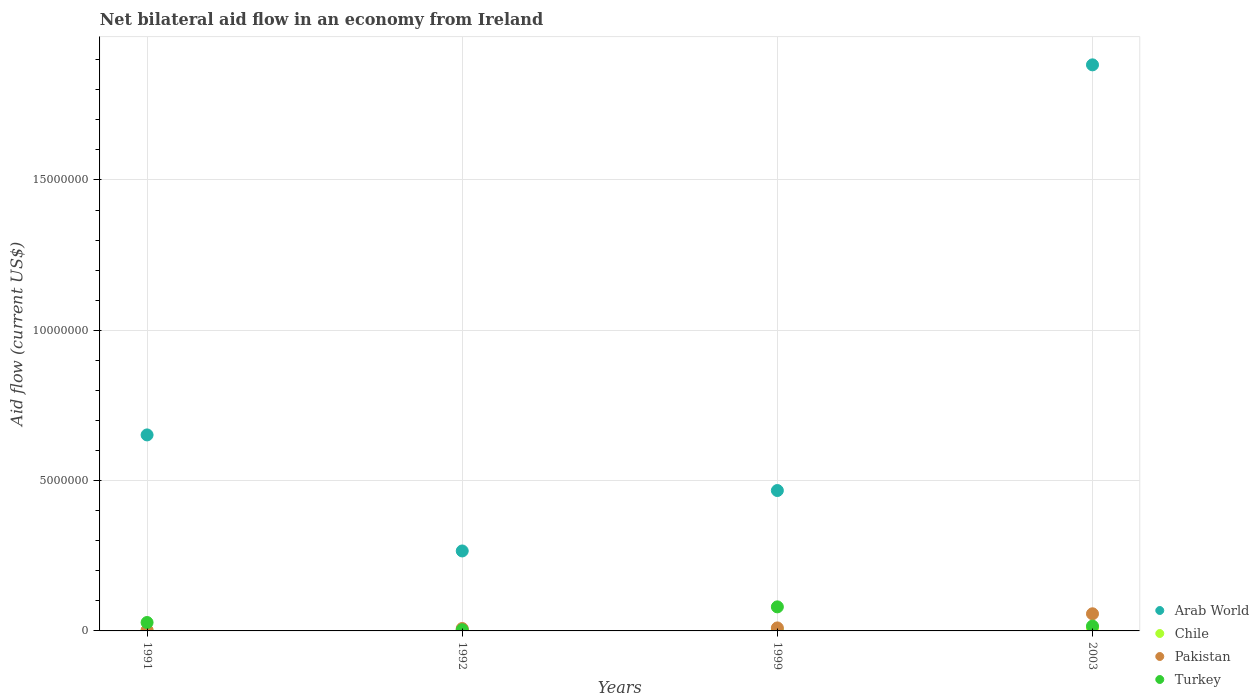How many different coloured dotlines are there?
Offer a terse response. 4. What is the net bilateral aid flow in Arab World in 1992?
Ensure brevity in your answer.  2.66e+06. Across all years, what is the minimum net bilateral aid flow in Arab World?
Your answer should be very brief. 2.66e+06. In which year was the net bilateral aid flow in Pakistan minimum?
Provide a short and direct response. 1991. What is the total net bilateral aid flow in Chile in the graph?
Keep it short and to the point. 1.70e+05. What is the difference between the net bilateral aid flow in Arab World in 1999 and that in 2003?
Provide a short and direct response. -1.42e+07. What is the difference between the net bilateral aid flow in Arab World in 1991 and the net bilateral aid flow in Chile in 2003?
Ensure brevity in your answer.  6.42e+06. What is the average net bilateral aid flow in Turkey per year?
Your answer should be very brief. 3.20e+05. In the year 1999, what is the difference between the net bilateral aid flow in Pakistan and net bilateral aid flow in Turkey?
Your response must be concise. -7.00e+05. What is the ratio of the net bilateral aid flow in Arab World in 1991 to that in 2003?
Give a very brief answer. 0.35. Is the difference between the net bilateral aid flow in Pakistan in 1992 and 2003 greater than the difference between the net bilateral aid flow in Turkey in 1992 and 2003?
Offer a very short reply. No. What is the difference between the highest and the second highest net bilateral aid flow in Turkey?
Give a very brief answer. 5.20e+05. What is the difference between the highest and the lowest net bilateral aid flow in Arab World?
Your response must be concise. 1.62e+07. Is the sum of the net bilateral aid flow in Turkey in 1992 and 1999 greater than the maximum net bilateral aid flow in Pakistan across all years?
Offer a terse response. Yes. Is it the case that in every year, the sum of the net bilateral aid flow in Pakistan and net bilateral aid flow in Turkey  is greater than the sum of net bilateral aid flow in Arab World and net bilateral aid flow in Chile?
Keep it short and to the point. No. Is it the case that in every year, the sum of the net bilateral aid flow in Turkey and net bilateral aid flow in Arab World  is greater than the net bilateral aid flow in Chile?
Your answer should be compact. Yes. How many dotlines are there?
Offer a very short reply. 4. How many years are there in the graph?
Keep it short and to the point. 4. What is the difference between two consecutive major ticks on the Y-axis?
Offer a very short reply. 5.00e+06. How many legend labels are there?
Your response must be concise. 4. What is the title of the graph?
Provide a short and direct response. Net bilateral aid flow in an economy from Ireland. Does "High income: OECD" appear as one of the legend labels in the graph?
Make the answer very short. No. What is the Aid flow (current US$) of Arab World in 1991?
Offer a very short reply. 6.52e+06. What is the Aid flow (current US$) of Chile in 1991?
Keep it short and to the point. 2.00e+04. What is the Aid flow (current US$) in Turkey in 1991?
Provide a short and direct response. 2.80e+05. What is the Aid flow (current US$) of Arab World in 1992?
Offer a terse response. 2.66e+06. What is the Aid flow (current US$) in Pakistan in 1992?
Provide a succinct answer. 8.00e+04. What is the Aid flow (current US$) of Arab World in 1999?
Make the answer very short. 4.67e+06. What is the Aid flow (current US$) in Chile in 1999?
Offer a terse response. 3.00e+04. What is the Aid flow (current US$) of Pakistan in 1999?
Provide a succinct answer. 1.00e+05. What is the Aid flow (current US$) of Turkey in 1999?
Your answer should be very brief. 8.00e+05. What is the Aid flow (current US$) of Arab World in 2003?
Keep it short and to the point. 1.88e+07. What is the Aid flow (current US$) in Pakistan in 2003?
Offer a very short reply. 5.70e+05. What is the Aid flow (current US$) in Turkey in 2003?
Your response must be concise. 1.60e+05. Across all years, what is the maximum Aid flow (current US$) in Arab World?
Your answer should be compact. 1.88e+07. Across all years, what is the maximum Aid flow (current US$) in Chile?
Provide a short and direct response. 1.00e+05. Across all years, what is the maximum Aid flow (current US$) in Pakistan?
Offer a terse response. 5.70e+05. Across all years, what is the minimum Aid flow (current US$) of Arab World?
Make the answer very short. 2.66e+06. Across all years, what is the minimum Aid flow (current US$) in Pakistan?
Give a very brief answer. 2.00e+04. What is the total Aid flow (current US$) in Arab World in the graph?
Provide a short and direct response. 3.27e+07. What is the total Aid flow (current US$) in Pakistan in the graph?
Your response must be concise. 7.70e+05. What is the total Aid flow (current US$) of Turkey in the graph?
Give a very brief answer. 1.28e+06. What is the difference between the Aid flow (current US$) in Arab World in 1991 and that in 1992?
Give a very brief answer. 3.86e+06. What is the difference between the Aid flow (current US$) in Pakistan in 1991 and that in 1992?
Provide a short and direct response. -6.00e+04. What is the difference between the Aid flow (current US$) of Arab World in 1991 and that in 1999?
Offer a terse response. 1.85e+06. What is the difference between the Aid flow (current US$) in Chile in 1991 and that in 1999?
Offer a very short reply. -10000. What is the difference between the Aid flow (current US$) of Pakistan in 1991 and that in 1999?
Offer a terse response. -8.00e+04. What is the difference between the Aid flow (current US$) of Turkey in 1991 and that in 1999?
Your answer should be very brief. -5.20e+05. What is the difference between the Aid flow (current US$) in Arab World in 1991 and that in 2003?
Provide a succinct answer. -1.23e+07. What is the difference between the Aid flow (current US$) in Pakistan in 1991 and that in 2003?
Give a very brief answer. -5.50e+05. What is the difference between the Aid flow (current US$) of Turkey in 1991 and that in 2003?
Offer a terse response. 1.20e+05. What is the difference between the Aid flow (current US$) of Arab World in 1992 and that in 1999?
Your answer should be very brief. -2.01e+06. What is the difference between the Aid flow (current US$) in Turkey in 1992 and that in 1999?
Provide a short and direct response. -7.60e+05. What is the difference between the Aid flow (current US$) of Arab World in 1992 and that in 2003?
Your response must be concise. -1.62e+07. What is the difference between the Aid flow (current US$) of Chile in 1992 and that in 2003?
Provide a succinct answer. -8.00e+04. What is the difference between the Aid flow (current US$) in Pakistan in 1992 and that in 2003?
Provide a short and direct response. -4.90e+05. What is the difference between the Aid flow (current US$) in Arab World in 1999 and that in 2003?
Offer a terse response. -1.42e+07. What is the difference between the Aid flow (current US$) of Pakistan in 1999 and that in 2003?
Keep it short and to the point. -4.70e+05. What is the difference between the Aid flow (current US$) in Turkey in 1999 and that in 2003?
Provide a succinct answer. 6.40e+05. What is the difference between the Aid flow (current US$) of Arab World in 1991 and the Aid flow (current US$) of Chile in 1992?
Keep it short and to the point. 6.50e+06. What is the difference between the Aid flow (current US$) in Arab World in 1991 and the Aid flow (current US$) in Pakistan in 1992?
Make the answer very short. 6.44e+06. What is the difference between the Aid flow (current US$) of Arab World in 1991 and the Aid flow (current US$) of Turkey in 1992?
Your answer should be compact. 6.48e+06. What is the difference between the Aid flow (current US$) of Chile in 1991 and the Aid flow (current US$) of Pakistan in 1992?
Give a very brief answer. -6.00e+04. What is the difference between the Aid flow (current US$) of Chile in 1991 and the Aid flow (current US$) of Turkey in 1992?
Keep it short and to the point. -2.00e+04. What is the difference between the Aid flow (current US$) of Pakistan in 1991 and the Aid flow (current US$) of Turkey in 1992?
Your response must be concise. -2.00e+04. What is the difference between the Aid flow (current US$) in Arab World in 1991 and the Aid flow (current US$) in Chile in 1999?
Offer a terse response. 6.49e+06. What is the difference between the Aid flow (current US$) in Arab World in 1991 and the Aid flow (current US$) in Pakistan in 1999?
Offer a very short reply. 6.42e+06. What is the difference between the Aid flow (current US$) in Arab World in 1991 and the Aid flow (current US$) in Turkey in 1999?
Keep it short and to the point. 5.72e+06. What is the difference between the Aid flow (current US$) of Chile in 1991 and the Aid flow (current US$) of Pakistan in 1999?
Your answer should be very brief. -8.00e+04. What is the difference between the Aid flow (current US$) of Chile in 1991 and the Aid flow (current US$) of Turkey in 1999?
Your response must be concise. -7.80e+05. What is the difference between the Aid flow (current US$) of Pakistan in 1991 and the Aid flow (current US$) of Turkey in 1999?
Provide a short and direct response. -7.80e+05. What is the difference between the Aid flow (current US$) of Arab World in 1991 and the Aid flow (current US$) of Chile in 2003?
Your answer should be compact. 6.42e+06. What is the difference between the Aid flow (current US$) in Arab World in 1991 and the Aid flow (current US$) in Pakistan in 2003?
Offer a terse response. 5.95e+06. What is the difference between the Aid flow (current US$) in Arab World in 1991 and the Aid flow (current US$) in Turkey in 2003?
Make the answer very short. 6.36e+06. What is the difference between the Aid flow (current US$) of Chile in 1991 and the Aid flow (current US$) of Pakistan in 2003?
Your answer should be very brief. -5.50e+05. What is the difference between the Aid flow (current US$) in Pakistan in 1991 and the Aid flow (current US$) in Turkey in 2003?
Provide a succinct answer. -1.40e+05. What is the difference between the Aid flow (current US$) of Arab World in 1992 and the Aid flow (current US$) of Chile in 1999?
Provide a short and direct response. 2.63e+06. What is the difference between the Aid flow (current US$) of Arab World in 1992 and the Aid flow (current US$) of Pakistan in 1999?
Your answer should be very brief. 2.56e+06. What is the difference between the Aid flow (current US$) of Arab World in 1992 and the Aid flow (current US$) of Turkey in 1999?
Your answer should be very brief. 1.86e+06. What is the difference between the Aid flow (current US$) of Chile in 1992 and the Aid flow (current US$) of Pakistan in 1999?
Ensure brevity in your answer.  -8.00e+04. What is the difference between the Aid flow (current US$) in Chile in 1992 and the Aid flow (current US$) in Turkey in 1999?
Offer a very short reply. -7.80e+05. What is the difference between the Aid flow (current US$) of Pakistan in 1992 and the Aid flow (current US$) of Turkey in 1999?
Provide a short and direct response. -7.20e+05. What is the difference between the Aid flow (current US$) of Arab World in 1992 and the Aid flow (current US$) of Chile in 2003?
Provide a short and direct response. 2.56e+06. What is the difference between the Aid flow (current US$) in Arab World in 1992 and the Aid flow (current US$) in Pakistan in 2003?
Give a very brief answer. 2.09e+06. What is the difference between the Aid flow (current US$) in Arab World in 1992 and the Aid flow (current US$) in Turkey in 2003?
Offer a very short reply. 2.50e+06. What is the difference between the Aid flow (current US$) of Chile in 1992 and the Aid flow (current US$) of Pakistan in 2003?
Give a very brief answer. -5.50e+05. What is the difference between the Aid flow (current US$) in Pakistan in 1992 and the Aid flow (current US$) in Turkey in 2003?
Keep it short and to the point. -8.00e+04. What is the difference between the Aid flow (current US$) of Arab World in 1999 and the Aid flow (current US$) of Chile in 2003?
Your answer should be very brief. 4.57e+06. What is the difference between the Aid flow (current US$) in Arab World in 1999 and the Aid flow (current US$) in Pakistan in 2003?
Offer a terse response. 4.10e+06. What is the difference between the Aid flow (current US$) of Arab World in 1999 and the Aid flow (current US$) of Turkey in 2003?
Your response must be concise. 4.51e+06. What is the difference between the Aid flow (current US$) of Chile in 1999 and the Aid flow (current US$) of Pakistan in 2003?
Make the answer very short. -5.40e+05. What is the difference between the Aid flow (current US$) in Chile in 1999 and the Aid flow (current US$) in Turkey in 2003?
Provide a succinct answer. -1.30e+05. What is the difference between the Aid flow (current US$) in Pakistan in 1999 and the Aid flow (current US$) in Turkey in 2003?
Your answer should be compact. -6.00e+04. What is the average Aid flow (current US$) of Arab World per year?
Offer a very short reply. 8.17e+06. What is the average Aid flow (current US$) in Chile per year?
Offer a very short reply. 4.25e+04. What is the average Aid flow (current US$) in Pakistan per year?
Give a very brief answer. 1.92e+05. What is the average Aid flow (current US$) in Turkey per year?
Offer a terse response. 3.20e+05. In the year 1991, what is the difference between the Aid flow (current US$) in Arab World and Aid flow (current US$) in Chile?
Provide a succinct answer. 6.50e+06. In the year 1991, what is the difference between the Aid flow (current US$) in Arab World and Aid flow (current US$) in Pakistan?
Provide a short and direct response. 6.50e+06. In the year 1991, what is the difference between the Aid flow (current US$) of Arab World and Aid flow (current US$) of Turkey?
Give a very brief answer. 6.24e+06. In the year 1992, what is the difference between the Aid flow (current US$) in Arab World and Aid flow (current US$) in Chile?
Give a very brief answer. 2.64e+06. In the year 1992, what is the difference between the Aid flow (current US$) in Arab World and Aid flow (current US$) in Pakistan?
Offer a terse response. 2.58e+06. In the year 1992, what is the difference between the Aid flow (current US$) of Arab World and Aid flow (current US$) of Turkey?
Your answer should be very brief. 2.62e+06. In the year 1992, what is the difference between the Aid flow (current US$) in Chile and Aid flow (current US$) in Turkey?
Keep it short and to the point. -2.00e+04. In the year 1999, what is the difference between the Aid flow (current US$) of Arab World and Aid flow (current US$) of Chile?
Your answer should be compact. 4.64e+06. In the year 1999, what is the difference between the Aid flow (current US$) of Arab World and Aid flow (current US$) of Pakistan?
Offer a terse response. 4.57e+06. In the year 1999, what is the difference between the Aid flow (current US$) in Arab World and Aid flow (current US$) in Turkey?
Give a very brief answer. 3.87e+06. In the year 1999, what is the difference between the Aid flow (current US$) in Chile and Aid flow (current US$) in Pakistan?
Your response must be concise. -7.00e+04. In the year 1999, what is the difference between the Aid flow (current US$) of Chile and Aid flow (current US$) of Turkey?
Keep it short and to the point. -7.70e+05. In the year 1999, what is the difference between the Aid flow (current US$) in Pakistan and Aid flow (current US$) in Turkey?
Give a very brief answer. -7.00e+05. In the year 2003, what is the difference between the Aid flow (current US$) in Arab World and Aid flow (current US$) in Chile?
Make the answer very short. 1.87e+07. In the year 2003, what is the difference between the Aid flow (current US$) in Arab World and Aid flow (current US$) in Pakistan?
Offer a terse response. 1.83e+07. In the year 2003, what is the difference between the Aid flow (current US$) in Arab World and Aid flow (current US$) in Turkey?
Provide a short and direct response. 1.87e+07. In the year 2003, what is the difference between the Aid flow (current US$) in Chile and Aid flow (current US$) in Pakistan?
Provide a succinct answer. -4.70e+05. In the year 2003, what is the difference between the Aid flow (current US$) of Chile and Aid flow (current US$) of Turkey?
Offer a very short reply. -6.00e+04. What is the ratio of the Aid flow (current US$) of Arab World in 1991 to that in 1992?
Give a very brief answer. 2.45. What is the ratio of the Aid flow (current US$) of Chile in 1991 to that in 1992?
Give a very brief answer. 1. What is the ratio of the Aid flow (current US$) in Turkey in 1991 to that in 1992?
Make the answer very short. 7. What is the ratio of the Aid flow (current US$) of Arab World in 1991 to that in 1999?
Offer a very short reply. 1.4. What is the ratio of the Aid flow (current US$) of Chile in 1991 to that in 1999?
Provide a short and direct response. 0.67. What is the ratio of the Aid flow (current US$) of Pakistan in 1991 to that in 1999?
Your answer should be compact. 0.2. What is the ratio of the Aid flow (current US$) of Arab World in 1991 to that in 2003?
Your answer should be very brief. 0.35. What is the ratio of the Aid flow (current US$) of Pakistan in 1991 to that in 2003?
Your answer should be compact. 0.04. What is the ratio of the Aid flow (current US$) of Turkey in 1991 to that in 2003?
Ensure brevity in your answer.  1.75. What is the ratio of the Aid flow (current US$) in Arab World in 1992 to that in 1999?
Offer a terse response. 0.57. What is the ratio of the Aid flow (current US$) in Chile in 1992 to that in 1999?
Your response must be concise. 0.67. What is the ratio of the Aid flow (current US$) in Pakistan in 1992 to that in 1999?
Your answer should be very brief. 0.8. What is the ratio of the Aid flow (current US$) in Arab World in 1992 to that in 2003?
Your response must be concise. 0.14. What is the ratio of the Aid flow (current US$) of Chile in 1992 to that in 2003?
Your answer should be compact. 0.2. What is the ratio of the Aid flow (current US$) in Pakistan in 1992 to that in 2003?
Offer a terse response. 0.14. What is the ratio of the Aid flow (current US$) of Turkey in 1992 to that in 2003?
Provide a succinct answer. 0.25. What is the ratio of the Aid flow (current US$) of Arab World in 1999 to that in 2003?
Make the answer very short. 0.25. What is the ratio of the Aid flow (current US$) in Chile in 1999 to that in 2003?
Your answer should be very brief. 0.3. What is the ratio of the Aid flow (current US$) of Pakistan in 1999 to that in 2003?
Provide a succinct answer. 0.18. What is the difference between the highest and the second highest Aid flow (current US$) of Arab World?
Make the answer very short. 1.23e+07. What is the difference between the highest and the second highest Aid flow (current US$) of Chile?
Offer a very short reply. 7.00e+04. What is the difference between the highest and the second highest Aid flow (current US$) in Pakistan?
Ensure brevity in your answer.  4.70e+05. What is the difference between the highest and the second highest Aid flow (current US$) of Turkey?
Your answer should be very brief. 5.20e+05. What is the difference between the highest and the lowest Aid flow (current US$) of Arab World?
Make the answer very short. 1.62e+07. What is the difference between the highest and the lowest Aid flow (current US$) of Chile?
Offer a very short reply. 8.00e+04. What is the difference between the highest and the lowest Aid flow (current US$) in Turkey?
Your answer should be compact. 7.60e+05. 